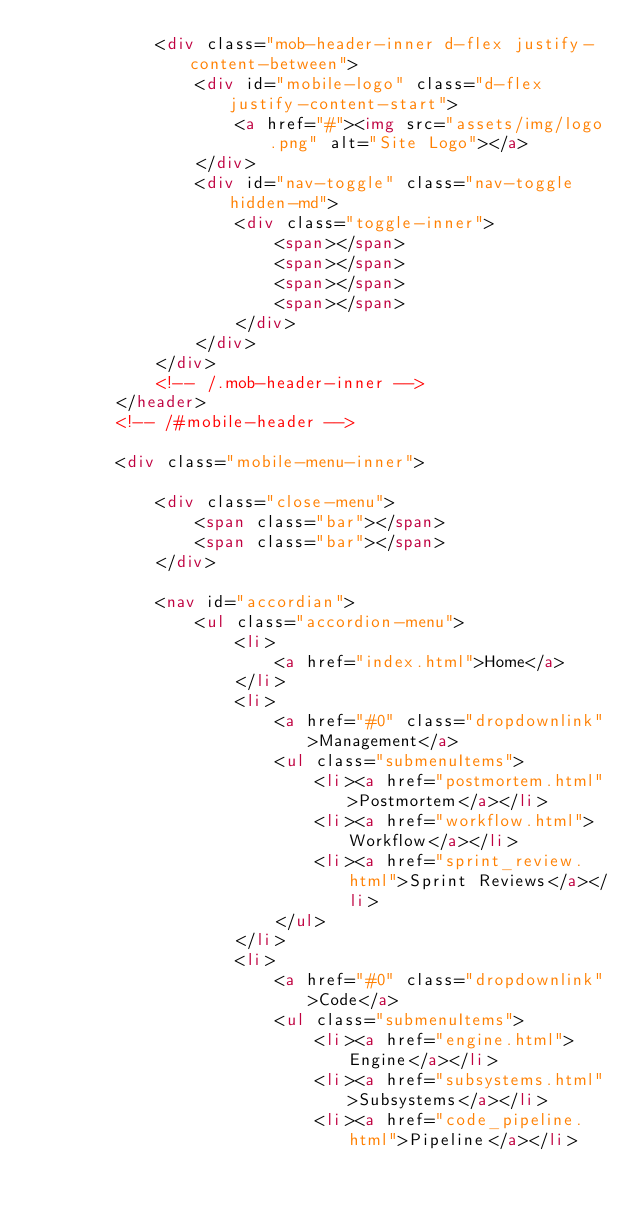<code> <loc_0><loc_0><loc_500><loc_500><_HTML_>			<div class="mob-header-inner d-flex justify-content-between">
				<div id="mobile-logo" class="d-flex justify-content-start">
					<a href="#"><img src="assets/img/logo.png" alt="Site Logo"></a>
				</div>
				<div id="nav-toggle" class="nav-toggle hidden-md">
					<div class="toggle-inner">
						<span></span>
						<span></span>
						<span></span>
						<span></span>
					</div>
				</div>
			</div>
			<!-- /.mob-header-inner -->
		</header>
		<!-- /#mobile-header -->

		<div class="mobile-menu-inner">

			<div class="close-menu">
				<span class="bar"></span>
				<span class="bar"></span>
			</div>

			<nav id="accordian">
				<ul class="accordion-menu">
					<li>
						<a href="index.html">Home</a>
					</li>
					<li>
						<a href="#0" class="dropdownlink">Management</a>
						<ul class="submenuItems">
							<li><a href="postmortem.html">Postmortem</a></li>
							<li><a href="workflow.html">Workflow</a></li>
							<li><a href="sprint_review.html">Sprint Reviews</a></li>
						</ul>
					</li>
					<li>
						<a href="#0" class="dropdownlink">Code</a>
						<ul class="submenuItems">
							<li><a href="engine.html">Engine</a></li>
							<li><a href="subsystems.html">Subsystems</a></li>
							<li><a href="code_pipeline.html">Pipeline</a></li></code> 